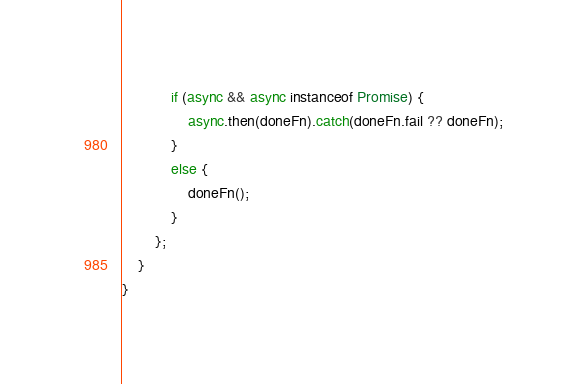<code> <loc_0><loc_0><loc_500><loc_500><_TypeScript_>
            if (async && async instanceof Promise) {
                async.then(doneFn).catch(doneFn.fail ?? doneFn);
            }
            else {
                doneFn();
            }
        };
    }
}
</code> 